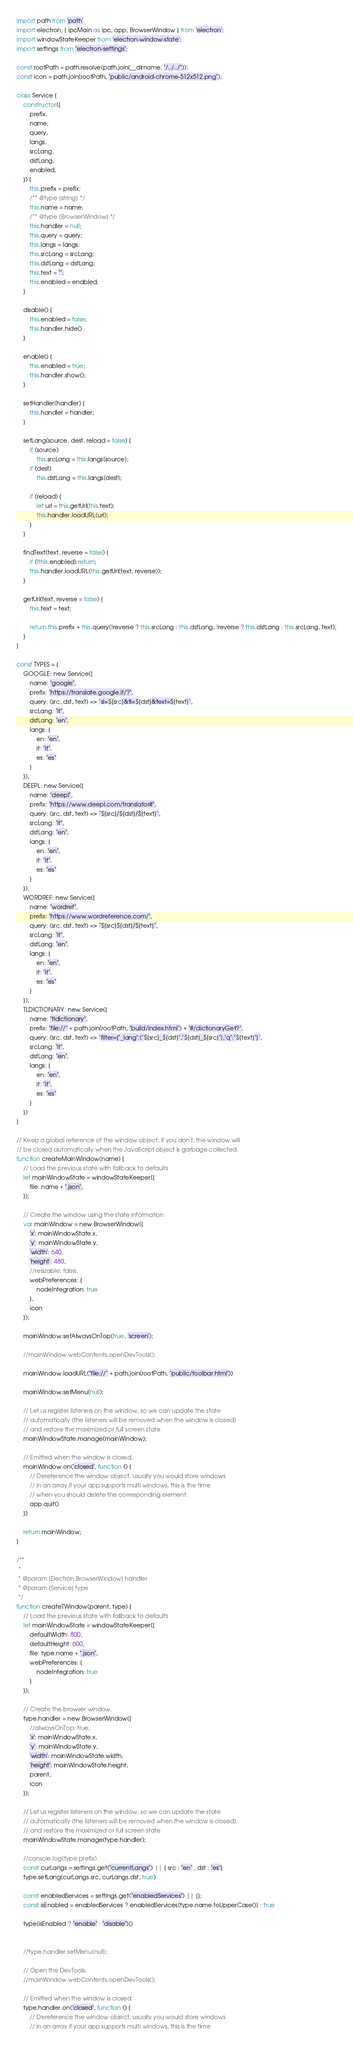<code> <loc_0><loc_0><loc_500><loc_500><_JavaScript_>import path from 'path'
import electron, { ipcMain as ipc, app, BrowserWindow } from 'electron';
import windowStateKeeper from 'electron-window-state';
import settings from "electron-settings";

const rootPath = path.resolve(path.join(__dirname, "/../../"));
const icon = path.join(rootPath, "public/android-chrome-512x512.png");

class Service {
    constructor({
        prefix,
        name,
        query,
        langs,
        srcLang,
        dstLang,
        enabled,
    }) {
        this.prefix = prefix;
        /** @type {string} */
        this.name = name;
        /** @type {BrowserWindow} */
        this.handler = null;
        this.query = query;
        this.langs = langs;
        this.srcLang = srcLang;
        this.dstLang = dstLang;
        this.text = "";
        this.enabled = enabled;
    }

    disable() {
        this.enabled = false;
        this.handler.hide()
    }

    enable() {
        this.enabled = true;
        this.handler.show();
    }

    setHandler(handler) {
        this.handler = handler;
    }

    setLang(source, dest, reload = false) {
        if (source)
            this.srcLang = this.langs[source];
        if (dest)
            this.dstLang = this.langs[dest];

        if (reload) {
            let url = this.getUrl(this.text);
            this.handler.loadURL(url);
        }
    }

    findText(text, reverse = false) {
        if (!this.enabled) return;
        this.handler.loadURL(this.getUrl(text, reverse));
    }

    getUrl(text, reverse = false) {
        this.text = text;

        return this.prefix + this.query(!reverse ? this.srcLang : this.dstLang, !reverse ? this.dstLang : this.srcLang, text);
    }
}

const TYPES = {
    GOOGLE: new Service({
        name: "google",
        prefix: "https://translate.google.it/?",
        query: (src, dst, text) => `sl=${src}&tl=${dst}&text=${text}`,
        srcLang: "it",
        dstLang: "en",
        langs: {
            en: "en",
            it: "it",
            es: "es"
        }
    }),
    DEEPL: new Service({
        name: "deepl",
        prefix: "https://www.deepl.com/translator#",
        query: (src, dst, text) => `${src}/${dst}/${text}`,
        srcLang: "it",
        dstLang: "en",
        langs: {
            en: "en",
            it: "it",
            es: "es"
        }
    }),
    WORDREF: new Service({
        name: "wordref",
        prefix: "https://www.wordreference.com/",
        query: (src, dst, text) => `${src}${dst}/${text}`,
        srcLang: "it",
        dstLang: "en",
        langs: {
            en: "en",
            it: "it",
            es: "es"
        }
    }),
    TLDICTIONARY: new Service({
        name: "tldictionary",
        prefix: "file://" + path.join(rootPath, "build/index.html") + "#/dictionaryGet?",
        query: (src, dst, text) => `filter={"_lang":["${src}_${dst}","${dst}_${src}"],"q":"${text}"}`,
        srcLang: "it",
        dstLang: "en",
        langs: {
            en: "en",
            it: "it",
            es: "es"
        }
    })
}

// Keep a global reference of the window object, if you don't, the window will
// be closed automatically when the JavaScript object is garbage collected.
function createMainWindow(name) {
    // Load the previous state with fallback to defaults
    let mainWindowState = windowStateKeeper({
        file: name + ".json",
    });

    // Create the window using the state information
    var mainWindow = new BrowserWindow({
        'x': mainWindowState.x,
        'y': mainWindowState.y,
        'width': 640,
        'height': 480,
        //resizable: false,
        webPreferences: {
            nodeIntegration: true
        },
        icon
    });

    mainWindow.setAlwaysOnTop(true, 'screen');

    //mainWindow.webContents.openDevTools();

    mainWindow.loadURL("file://" + path.join(rootPath, "public/toolbar.html"))

    mainWindow.setMenu(null);

    // Let us register listeners on the window, so we can update the state
    // automatically (the listeners will be removed when the window is closed)
    // and restore the maximized or full screen state
    mainWindowState.manage(mainWindow);

    // Emitted when the window is closed.
    mainWindow.on('closed', function () {
        // Dereference the window object, usually you would store windows
        // in an array if your app supports multi windows, this is the time
        // when you should delete the corresponding element.
        app.quit()
    })

    return mainWindow;
}

/**
 * 
 * @param {Electron.BrowserWindow} handler 
 * @param {Service} type 
 */
function createTWindow(parent, type) {
    // Load the previous state with fallback to defaults
    let mainWindowState = windowStateKeeper({
        defaultWidth: 800,
        defaultHeight: 600,
        file: type.name + ".json",
        webPreferences: {
            nodeIntegration: true
        }
    });

    // Create the browser window.
    type.handler = new BrowserWindow({
        //alwaysOnTop: true,
        'x': mainWindowState.x,
        'y': mainWindowState.y,
        'width': mainWindowState.width,
        'height': mainWindowState.height,
        parent,
        icon
    });

    // Let us register listeners on the window, so we can update the state
    // automatically (the listeners will be removed when the window is closed)
    // and restore the maximized or full screen state
    mainWindowState.manage(type.handler);

    //console.log(type.prefix)
    const curLangs = settings.get("currentLangs") || { src : "en" , dst : "es"}
    type.setLang(curLangs.src, curLangs.dst, true)

    const enabledServices = settings.get("enabledServices") || {};
    const isEnabled = enabledServices ? enabledServices[type.name.toUpperCase()] : true

    type[isEnabled ? "enable" : "disable"]()


    //type.handler.setMenu(null);

    // Open the DevTools.
    //mainWindow.webContents.openDevTools();

    // Emitted when the window is closed.
    type.handler.on('closed', function () {
        // Dereference the window object, usually you would store windows
        // in an array if your app supports multi windows, this is the time</code> 